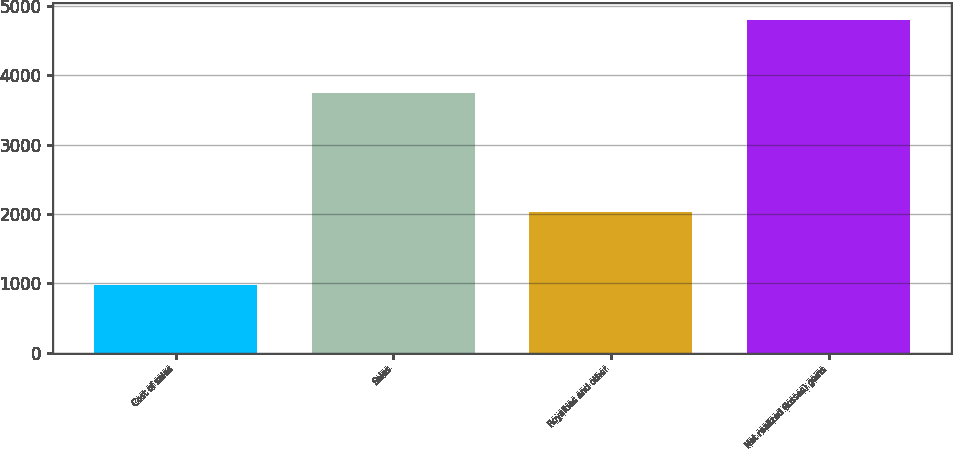Convert chart. <chart><loc_0><loc_0><loc_500><loc_500><bar_chart><fcel>Cost of sales<fcel>Sales<fcel>Royalties and other<fcel>Net realized (losses) gains<nl><fcel>973<fcel>3741<fcel>2028<fcel>4796<nl></chart> 